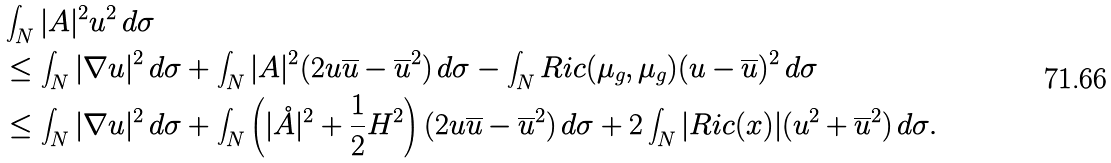Convert formula to latex. <formula><loc_0><loc_0><loc_500><loc_500>& \int _ { N } | A | ^ { 2 } u ^ { 2 } \, d \sigma \\ & \leq \int _ { N } | \nabla u | ^ { 2 } \, d \sigma + \int _ { N } | A | ^ { 2 } ( 2 u \overline { u } - \overline { u } ^ { 2 } ) \, d \sigma - \int _ { N } R i c ( \mu _ { g } , \mu _ { g } ) ( u - \overline { u } ) ^ { 2 } \, d \sigma \\ & \leq \int _ { N } | \nabla u | ^ { 2 } \, d \sigma + \int _ { N } \left ( | \mathring { A } | ^ { 2 } + \frac { 1 } { 2 } H ^ { 2 } \right ) ( 2 u \overline { u } - \overline { u } ^ { 2 } ) \, d \sigma + 2 \int _ { N } | R i c ( x ) | ( u ^ { 2 } + \overline { u } ^ { 2 } ) \, d \sigma .</formula> 